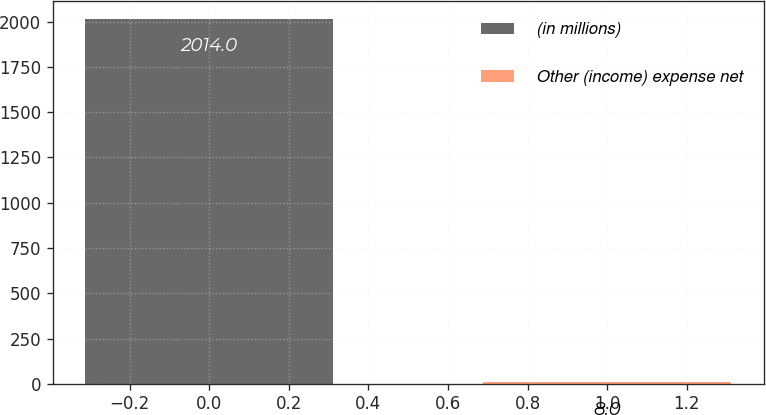Convert chart. <chart><loc_0><loc_0><loc_500><loc_500><bar_chart><fcel>(in millions)<fcel>Other (income) expense net<nl><fcel>2014<fcel>8<nl></chart> 